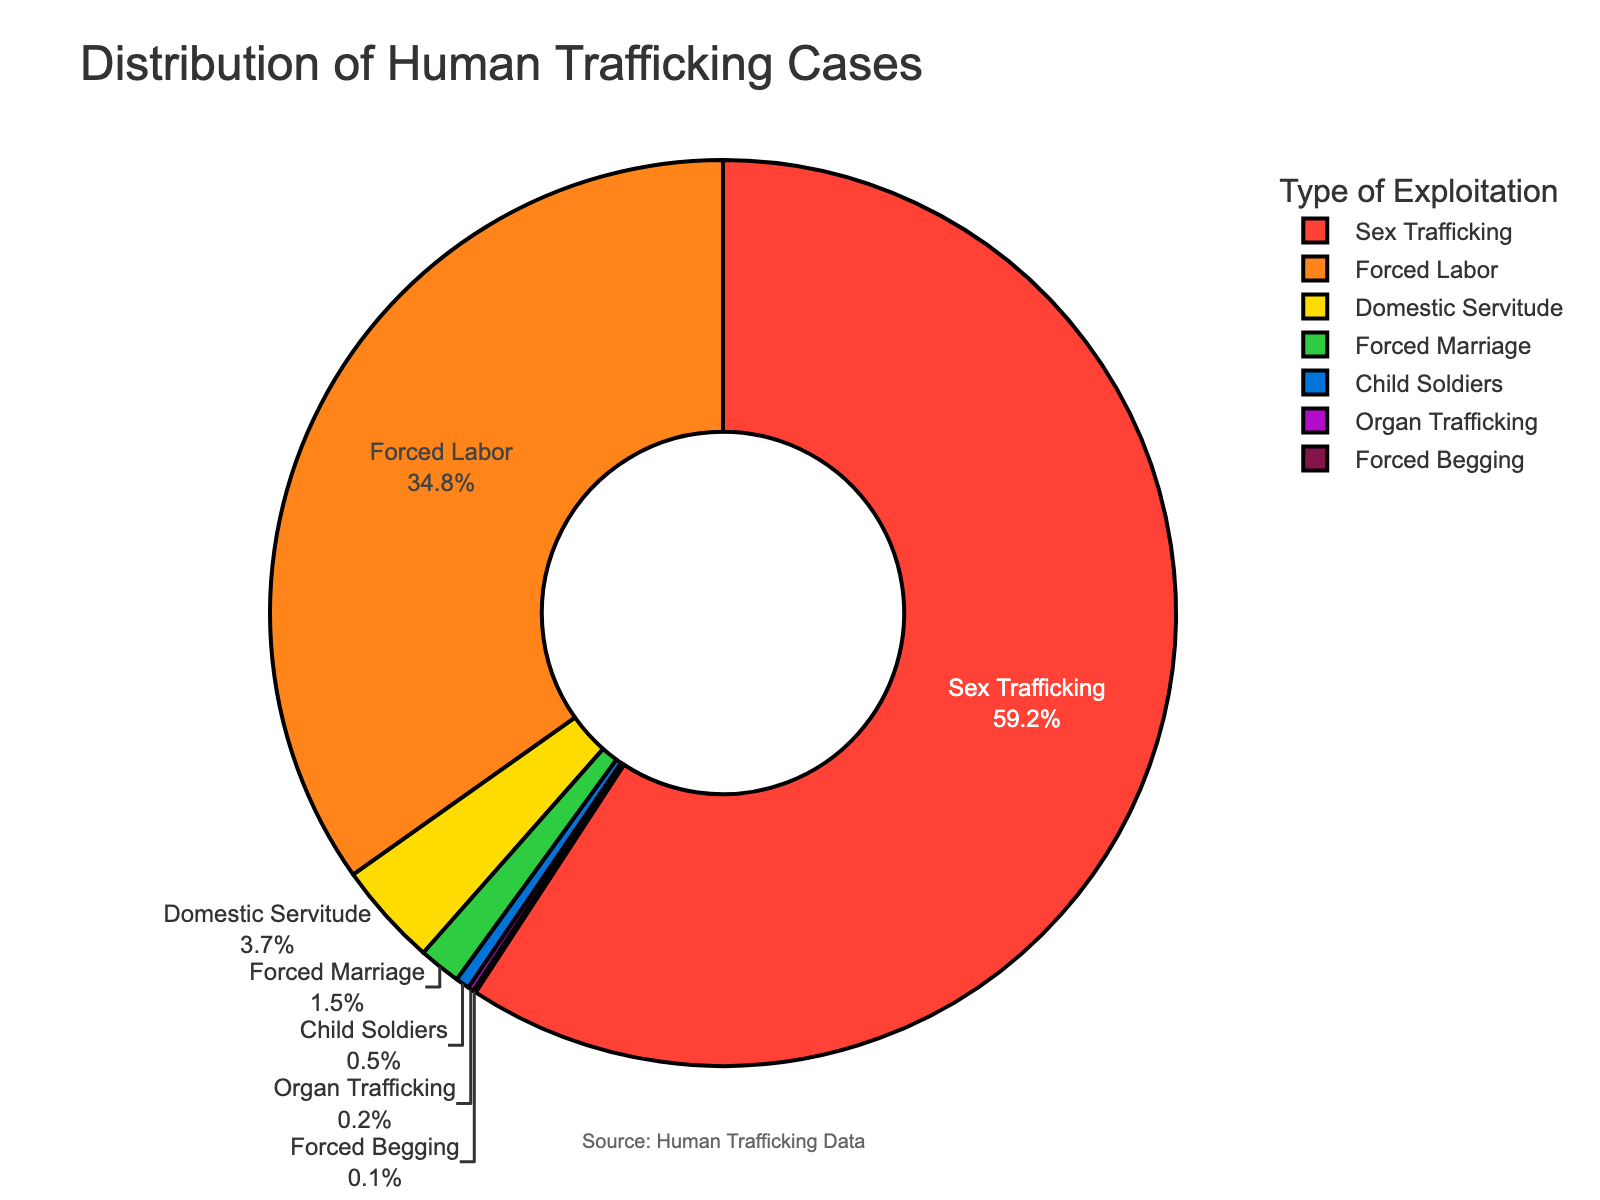What type of exploitation is the most common in human trafficking cases? The pie chart shows that the segment for Sex Trafficking has the largest percentage compared to other types of exploitation, indicating it is the most common.
Answer: Sex Trafficking What is the combined percentage of Forced Labor and Domestic Servitude? The percentage for Forced Labor is 34.8% and for Domestic Servitude is 3.7%. Adding them together gives 34.8 + 3.7 = 38.5%.
Answer: 38.5% Which type of exploitation has a smaller percentage: Forced Marriage or Child Soldiers? The pie chart shows the percentage for Forced Marriage is 1.5%, and for Child Soldiers, it is 0.5%. Since 0.5% is less than 1.5%, Child Soldiers has the smaller percentage.
Answer: Child Soldiers What is the total percentage of all types of exploitation listed that have less than 1% each? The types under 1% include Forced Marriage (1.5%), Child Soldiers (0.5%), Organ Trafficking (0.2%), and Forced Begging (0.1%). Adding these percentages: 0.5 + 0.2 + 0.1 = 0.8%.
Answer: 0.8% Which segment in the pie chart is represented by the color green? Viewing the legend in the pie chart, the green color corresponds to the type of exploitation listed as Domestic Servitude.
Answer: Domestic Servitude How much greater is the percentage of Sex Trafficking compared to Forced Labor? The percentage for Sex Trafficking is 59.2% and for Forced Labor is 34.8%. The difference is calculated as 59.2 - 34.8 = 24.4%.
Answer: 24.4% What is the smallest type of exploitation listed in the pie chart? The pie chart shows that the smallest percentage for any type of exploitation is for Forced Begging, which is 0.1%.
Answer: Forced Begging What percentage of human trafficking cases does Forced Marriage represent? According to the pie chart, Forced Marriage accounts for 1.5% of human trafficking cases.
Answer: 1.5% Is the percentage of Domestic Servitude greater than 3%? The pie chart indicates that Domestic Servitude represents 3.7% of the cases, which is indeed greater than 3%.
Answer: Yes, 3.7% If you combine the percentages for Child Soldiers, Organ Trafficking, and Forced Begging, is it more or less than 1%? Combining the percentages for Child Soldiers (0.5%), Organ Trafficking (0.2%), and Forced Begging (0.1%), we get 0.5 + 0.2 + 0.1 = 0.8%. Since 0.8% is less than 1%, the combined percentage is less than 1%.
Answer: Less than 1% 